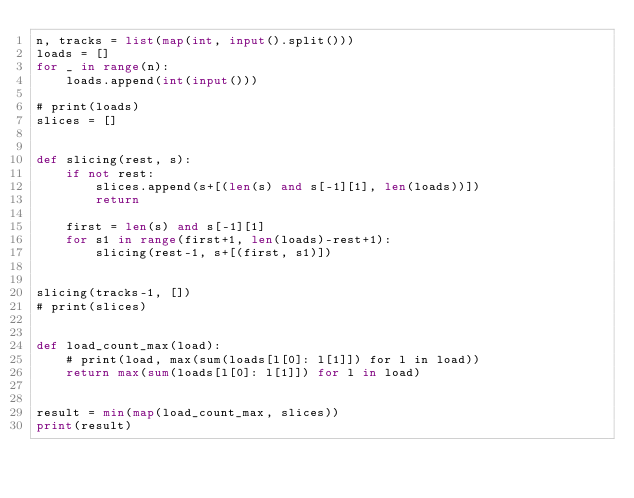Convert code to text. <code><loc_0><loc_0><loc_500><loc_500><_Python_>n, tracks = list(map(int, input().split()))
loads = []
for _ in range(n):
    loads.append(int(input()))

# print(loads)
slices = []


def slicing(rest, s):
    if not rest:
        slices.append(s+[(len(s) and s[-1][1], len(loads))])
        return

    first = len(s) and s[-1][1]
    for s1 in range(first+1, len(loads)-rest+1):
        slicing(rest-1, s+[(first, s1)])


slicing(tracks-1, [])
# print(slices)


def load_count_max(load):
    # print(load, max(sum(loads[l[0]: l[1]]) for l in load))
    return max(sum(loads[l[0]: l[1]]) for l in load)


result = min(map(load_count_max, slices))
print(result)

</code> 